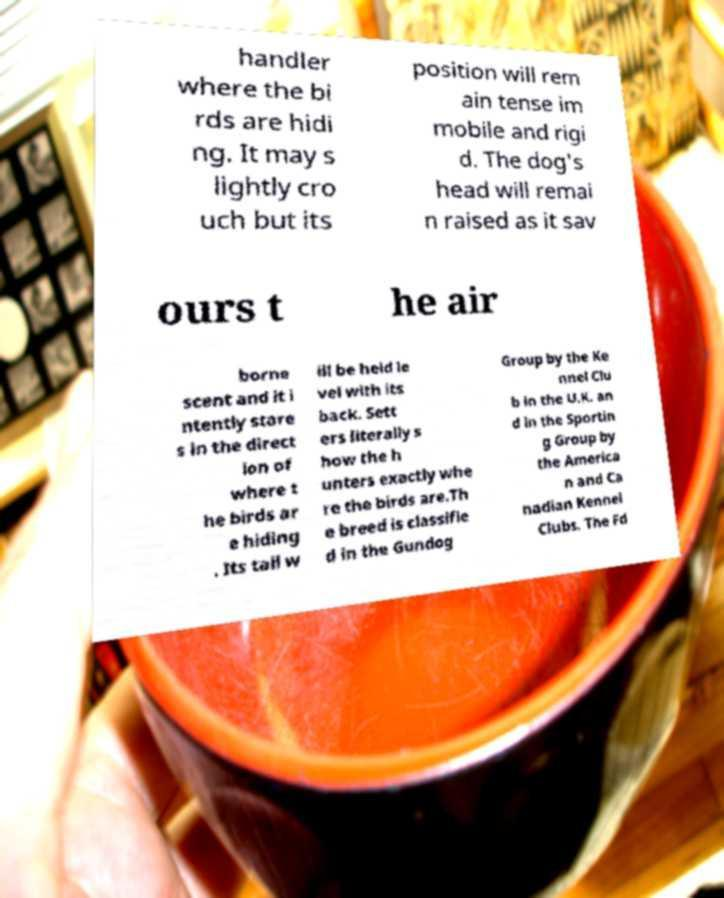Could you extract and type out the text from this image? handler where the bi rds are hidi ng. It may s lightly cro uch but its position will rem ain tense im mobile and rigi d. The dog's head will remai n raised as it sav ours t he air borne scent and it i ntently stare s in the direct ion of where t he birds ar e hiding . Its tail w ill be held le vel with its back. Sett ers literally s how the h unters exactly whe re the birds are.Th e breed is classifie d in the Gundog Group by the Ke nnel Clu b in the U.K. an d in the Sportin g Group by the America n and Ca nadian Kennel Clubs. The Fd 